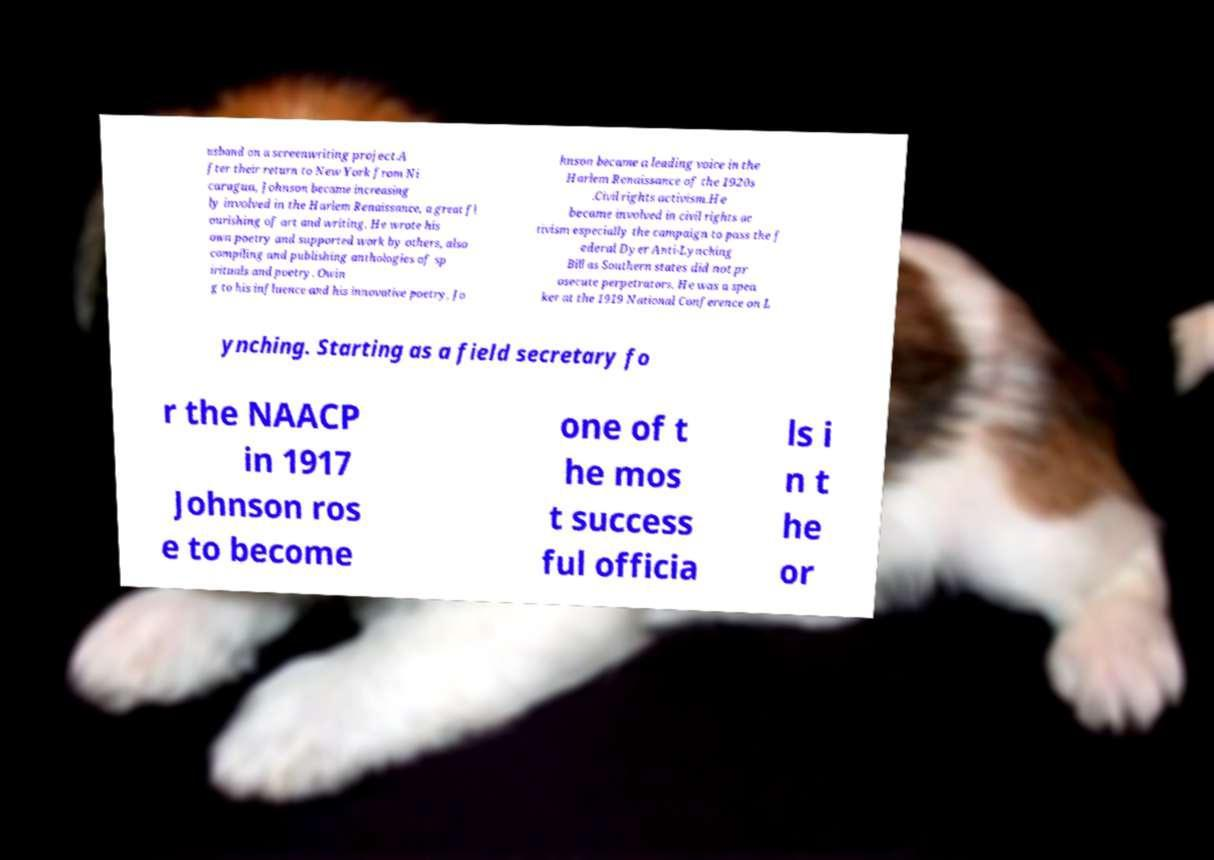I need the written content from this picture converted into text. Can you do that? usband on a screenwriting project.A fter their return to New York from Ni caragua, Johnson became increasing ly involved in the Harlem Renaissance, a great fl ourishing of art and writing. He wrote his own poetry and supported work by others, also compiling and publishing anthologies of sp irituals and poetry. Owin g to his influence and his innovative poetry, Jo hnson became a leading voice in the Harlem Renaissance of the 1920s .Civil rights activism.He became involved in civil rights ac tivism especially the campaign to pass the f ederal Dyer Anti-Lynching Bill as Southern states did not pr osecute perpetrators. He was a spea ker at the 1919 National Conference on L ynching. Starting as a field secretary fo r the NAACP in 1917 Johnson ros e to become one of t he mos t success ful officia ls i n t he or 